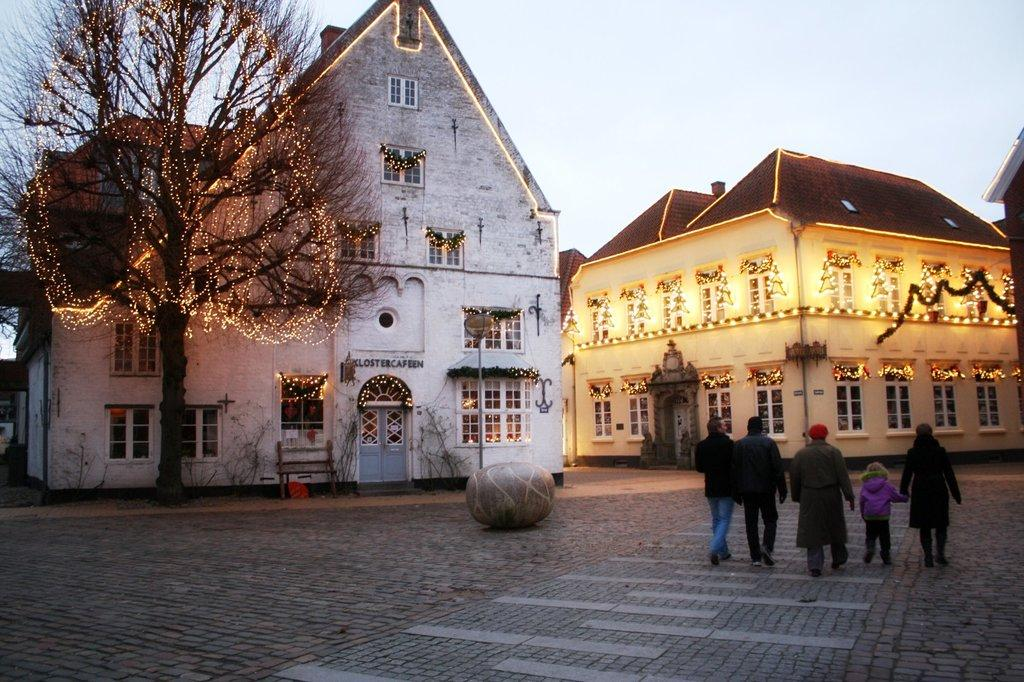Who or what is present in the image? There are people in the image. What can be seen on the left side of the image? There is a tree on the left side of the image. What is visible in the background of the image? There are houses in the background of the image, and the sky is also visible. How are the houses decorated in the image? The houses are decorated with lights. How many rings are visible on the people's fingers in the image? There is no information about rings on the people's fingers in the image, so we cannot determine the number of rings. What type of body is present in the image? The image contains people, but there is no specific body or creature mentioned in the facts provided. 